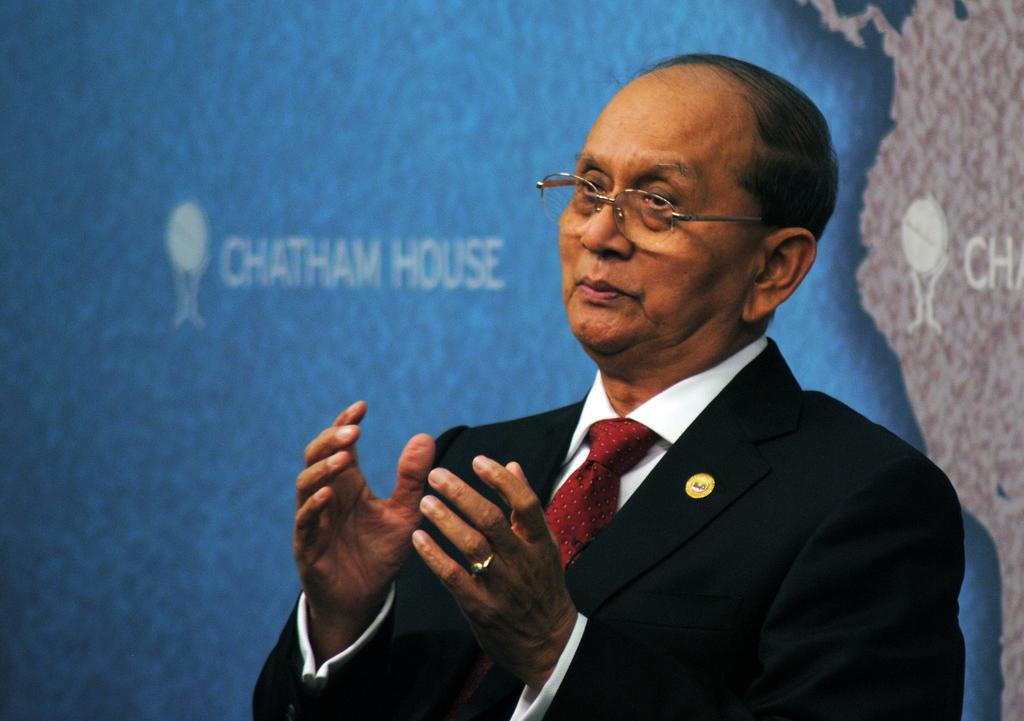Can you describe this image briefly? In this image there is a man, he is wearing a suit and a tie, in the background there is a map. 